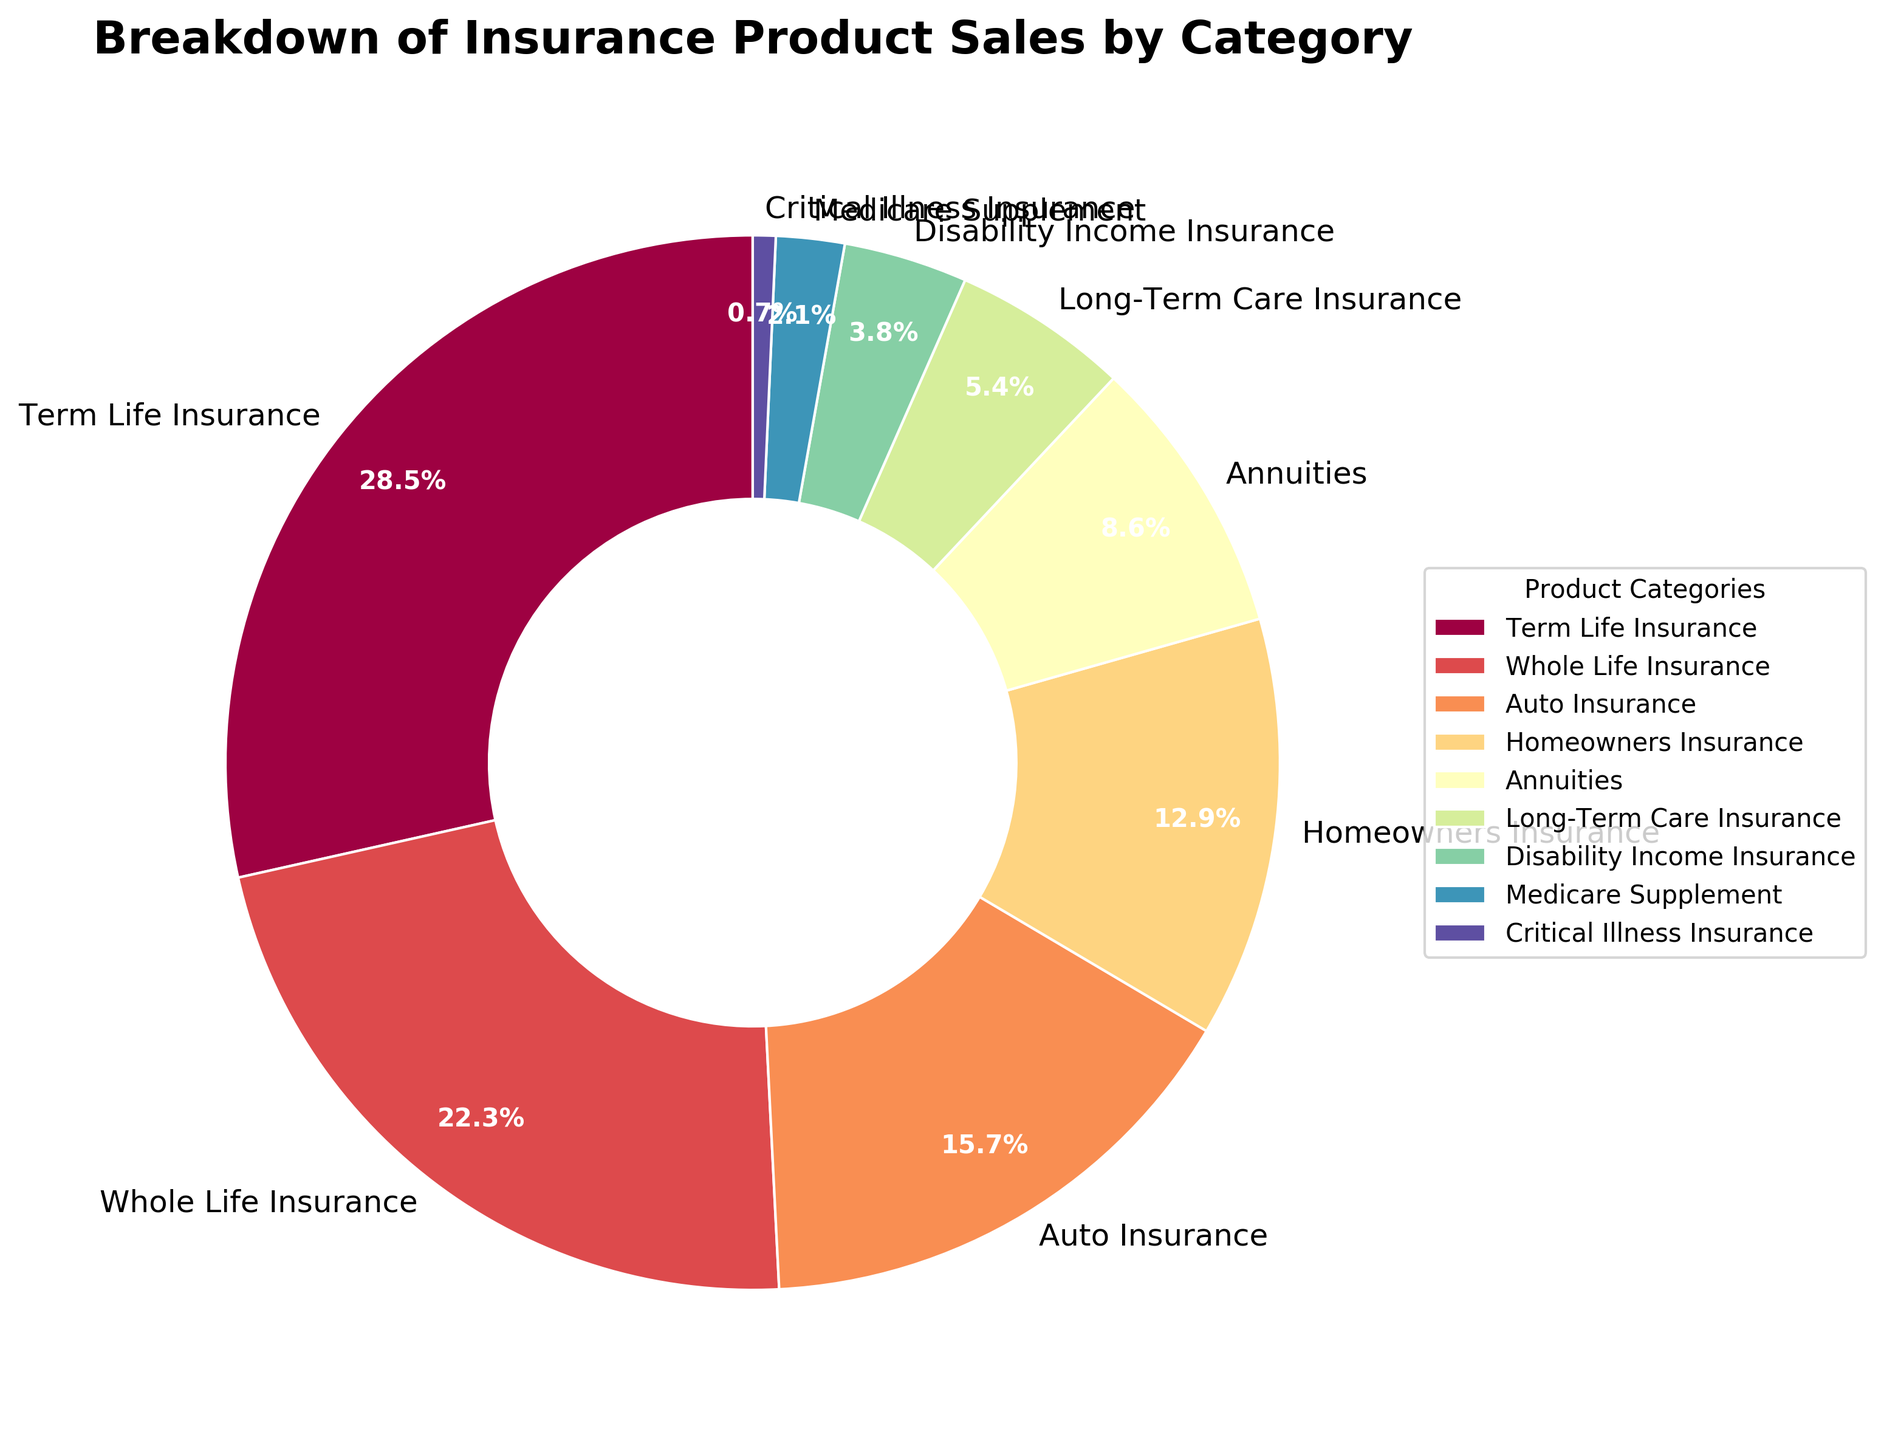Which insurance product category has the highest sales percentage? The wedge representing Term Life Insurance is the largest in the pie chart, indicating it has the highest sales percentage.
Answer: Term Life Insurance What is the combined sales percentage of Auto Insurance and Homeowners Insurance? The sales percentages for Auto Insurance and Homeowners Insurance are 15.7% and 12.9%, respectively. Adding them gives 15.7 + 12.9 = 28.6%.
Answer: 28.6% Which category has a higher sales percentage, Whole Life Insurance or Annuities? The sales percentage for Whole Life Insurance is 22.3%, while for Annuities, it is 8.6%. Therefore, Whole Life Insurance has a higher sales percentage.
Answer: Whole Life Insurance What is the difference in sales percentage between Term Life Insurance and Disability Income Insurance? The sales percentage of Term Life Insurance is 28.5%, and for Disability Income Insurance, it is 3.8%. The difference is 28.5 - 3.8 = 24.7%.
Answer: 24.7% Identify the three insurance product categories with the lowest sales percentages. The wedges for Critical Illness Insurance (0.7%), Medicare Supplement (2.1%), and Disability Income Insurance (3.8%) are the smallest in the pie chart, indicating they have the lowest sales percentages.
Answer: Critical Illness Insurance, Medicare Supplement, Disability Income Insurance Compare and state the combined sales percentage of Long-Term Care Insurance and Medicare Supplement against Homeowners Insurance. Long-Term Care Insurance has 5.4% and Medicare Supplement has 2.1%; their combined percentage is 5.4 + 2.1 = 7.5%. Homeowners Insurance has 12.9%, which is higher than 7.5%.
Answer: Homeowners Insurance Which color represents Whole Life Insurance in the pie chart? The color scheme used in the pie chart is spectral, and each segment is clearly separated by category labels. Whole Life Insurance is second from the largest wedge, making it easy to identify by its distinct color.
Answer: The color representing Whole Life Insurance How many categories have a sales percentage of less than 10% and what are they? The slices representing sales less than 10% are for Annuities (8.6%), Long-Term Care Insurance (5.4%), Disability Income Insurance (3.8%), Medicare Supplement (2.1%), and Critical Illness Insurance (0.7%), totaling five categories.
Answer: 5 categories: Annuities, Long-Term Care Insurance, Disability Income Insurance, Medicare Supplement, Critical Illness Insurance If the sales percentage for Term Life Insurance increased by 5%, what would its new percentage be? The current sales percentage for Term Life Insurance is 28.5%. Adding 5% to this gives 28.5 + 5 = 33.5%.
Answer: 33.5% What is the average sales percentage for Term Life Insurance, Whole Life Insurance, and Auto Insurance? The sales percentages for Term Life Insurance, Whole Life Insurance, and Auto Insurance are 28.5%, 22.3%, and 15.7%, respectively. The sum is 28.5 + 22.3 + 15.7 = 66.5%. The average is 66.5 / 3 = 22.17%.
Answer: 22.17% 